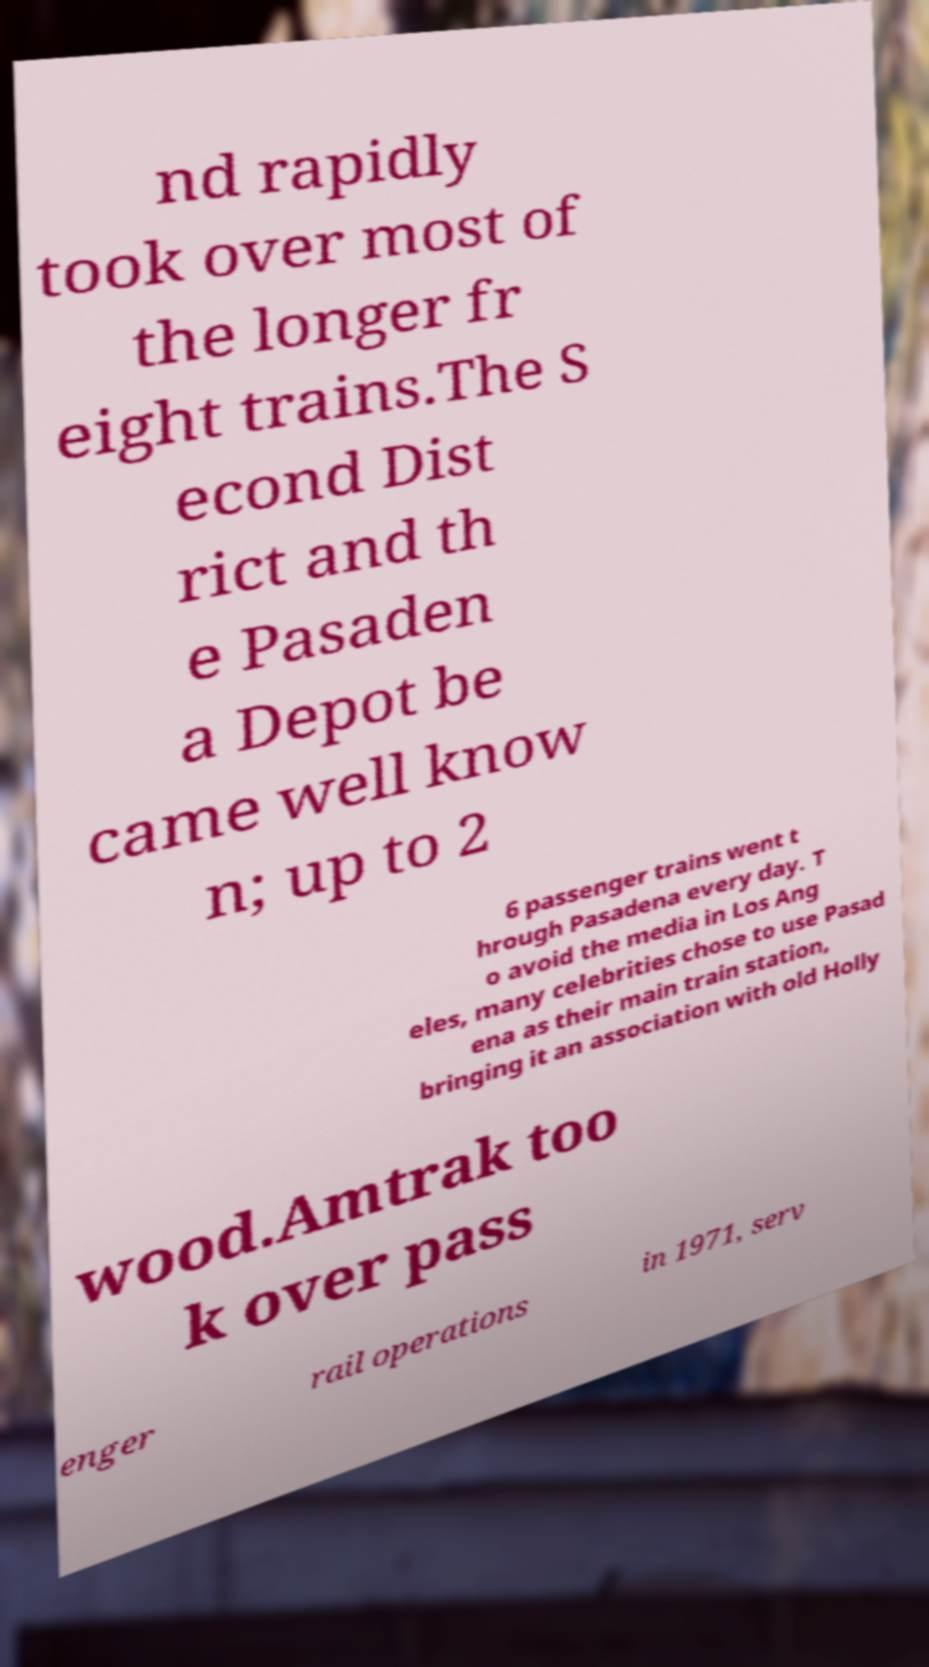Can you accurately transcribe the text from the provided image for me? nd rapidly took over most of the longer fr eight trains.The S econd Dist rict and th e Pasaden a Depot be came well know n; up to 2 6 passenger trains went t hrough Pasadena every day. T o avoid the media in Los Ang eles, many celebrities chose to use Pasad ena as their main train station, bringing it an association with old Holly wood.Amtrak too k over pass enger rail operations in 1971, serv 